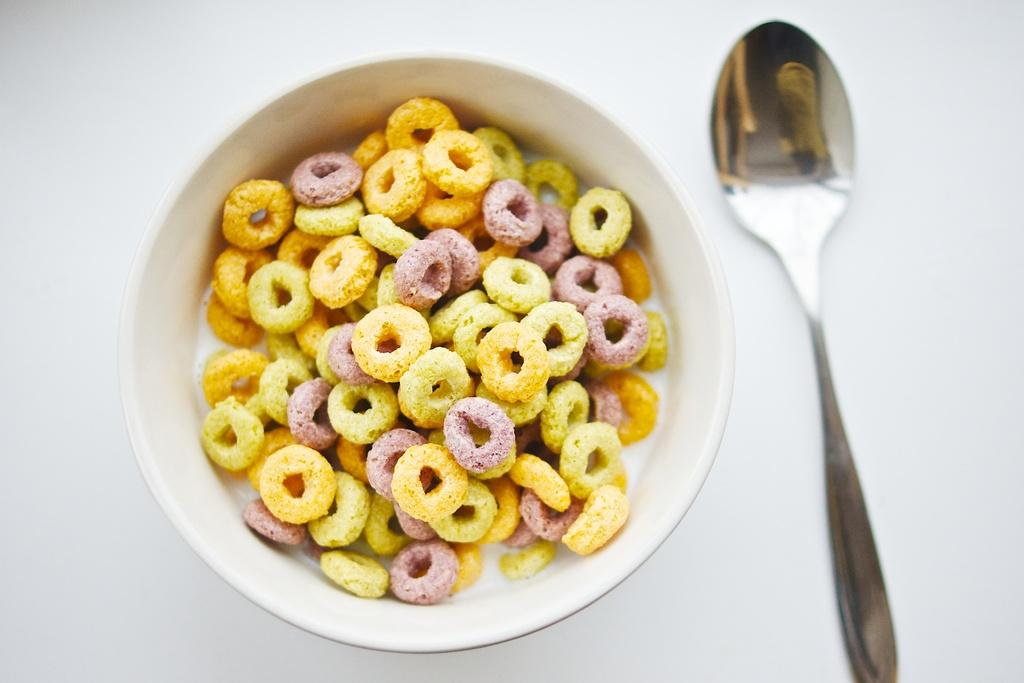What is the main object in the center of the image? There is a table in the center of the image. What is on top of the table? On the table, there is a bowl. What is used to eat the food in the bowl? There is a spoon on the table. What is inside the bowl? The bowl contains food items. How many pizzas are stacked in the pail in the image? There is no pail or pizzas present in the image. 